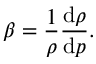<formula> <loc_0><loc_0><loc_500><loc_500>\beta = { \frac { 1 } { \rho } } { \frac { d \rho } { d p } } .</formula> 